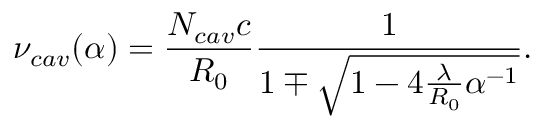<formula> <loc_0><loc_0><loc_500><loc_500>\nu _ { c a v } ( \alpha ) = \frac { N _ { c a v } c } { R _ { 0 } } \frac { 1 } { 1 \mp \sqrt { 1 - 4 \frac { \lambda } { R _ { 0 } } \alpha ^ { - 1 } } } .</formula> 